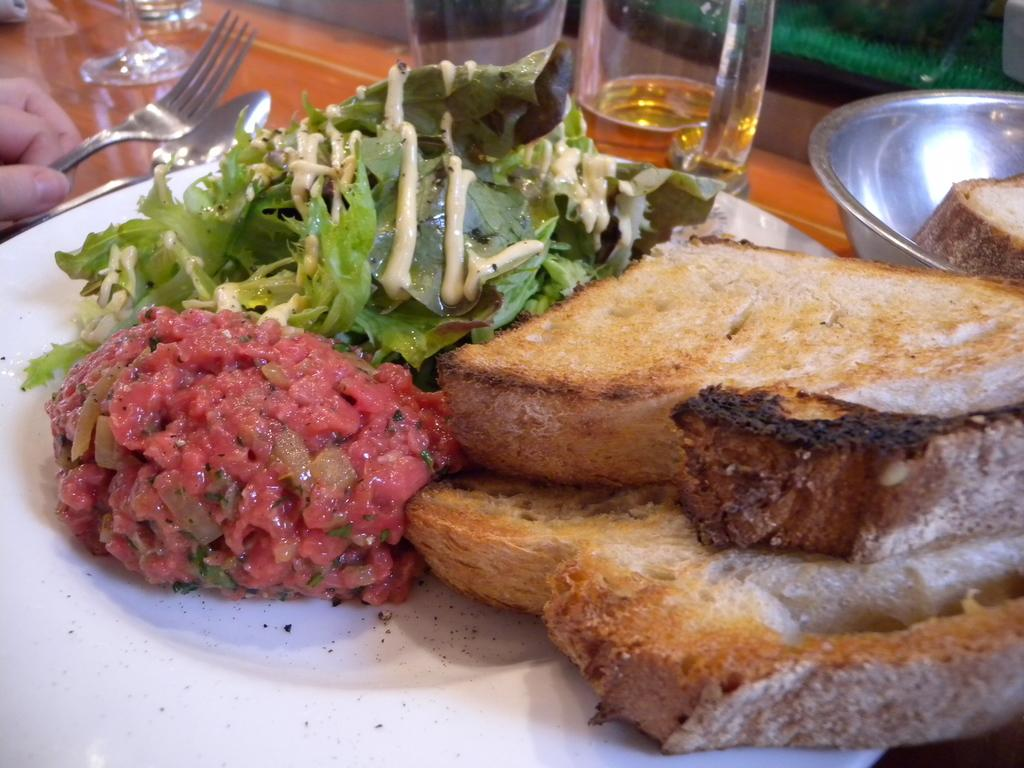What is the color of the plate that contains food in the image? The plate that contains food is white in color. What type of tableware can be seen in the image besides the plate? There are glasses, a bowl, and spoons in the image. What is the color of the surface on which the objects are placed? The surface is brown in color. What is a person holding in the image? A person is holding a fork in the image. Are there any bushes visible in the image? No, there are no bushes present in the image. Is there a yak in the image? No, there is no yak in the image. 